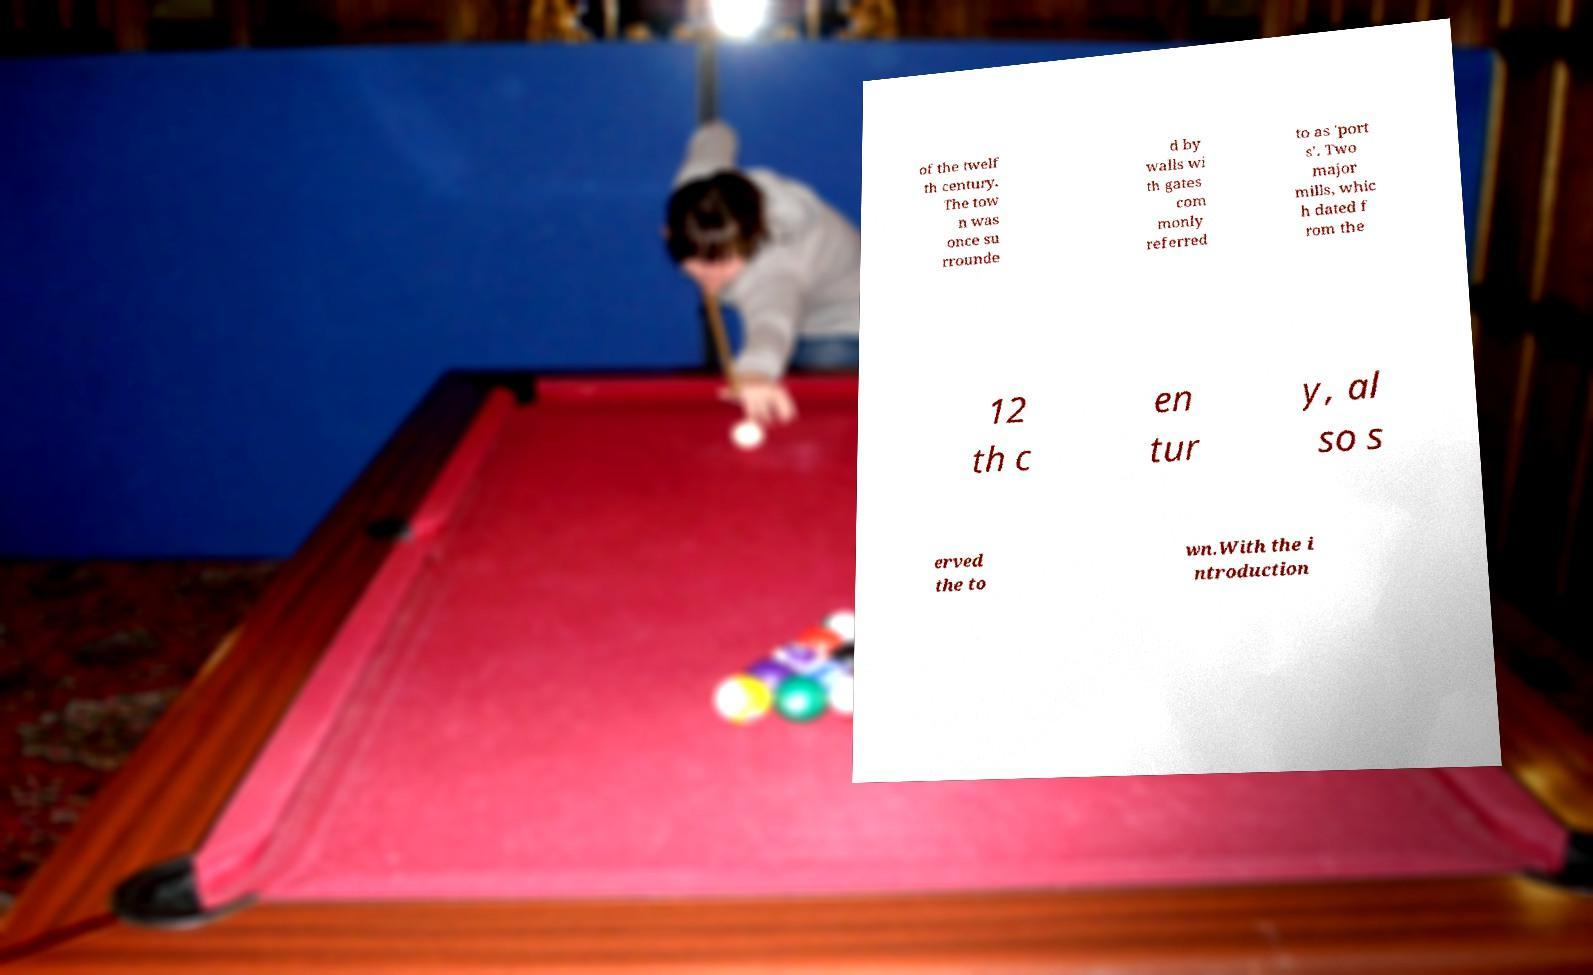Can you accurately transcribe the text from the provided image for me? of the twelf th century. The tow n was once su rrounde d by walls wi th gates com monly referred to as 'port s'. Two major mills, whic h dated f rom the 12 th c en tur y, al so s erved the to wn.With the i ntroduction 